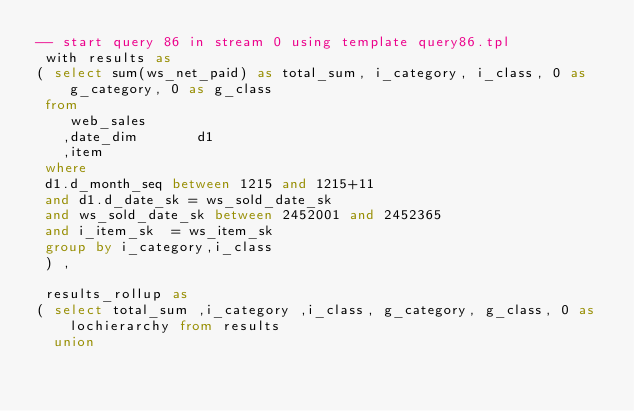Convert code to text. <code><loc_0><loc_0><loc_500><loc_500><_SQL_>-- start query 86 in stream 0 using template query86.tpl
 with results as
( select sum(ws_net_paid) as total_sum, i_category, i_class, 0 as g_category, 0 as g_class 
 from
    web_sales
   ,date_dim       d1
   ,item
 where
 d1.d_month_seq between 1215 and 1215+11
 and d1.d_date_sk = ws_sold_date_sk
 and ws_sold_date_sk between 2452001 and 2452365
 and i_item_sk  = ws_item_sk
 group by i_category,i_class
 ) ,

 results_rollup as
( select total_sum ,i_category ,i_class, g_category, g_class, 0 as lochierarchy from results
  union</code> 